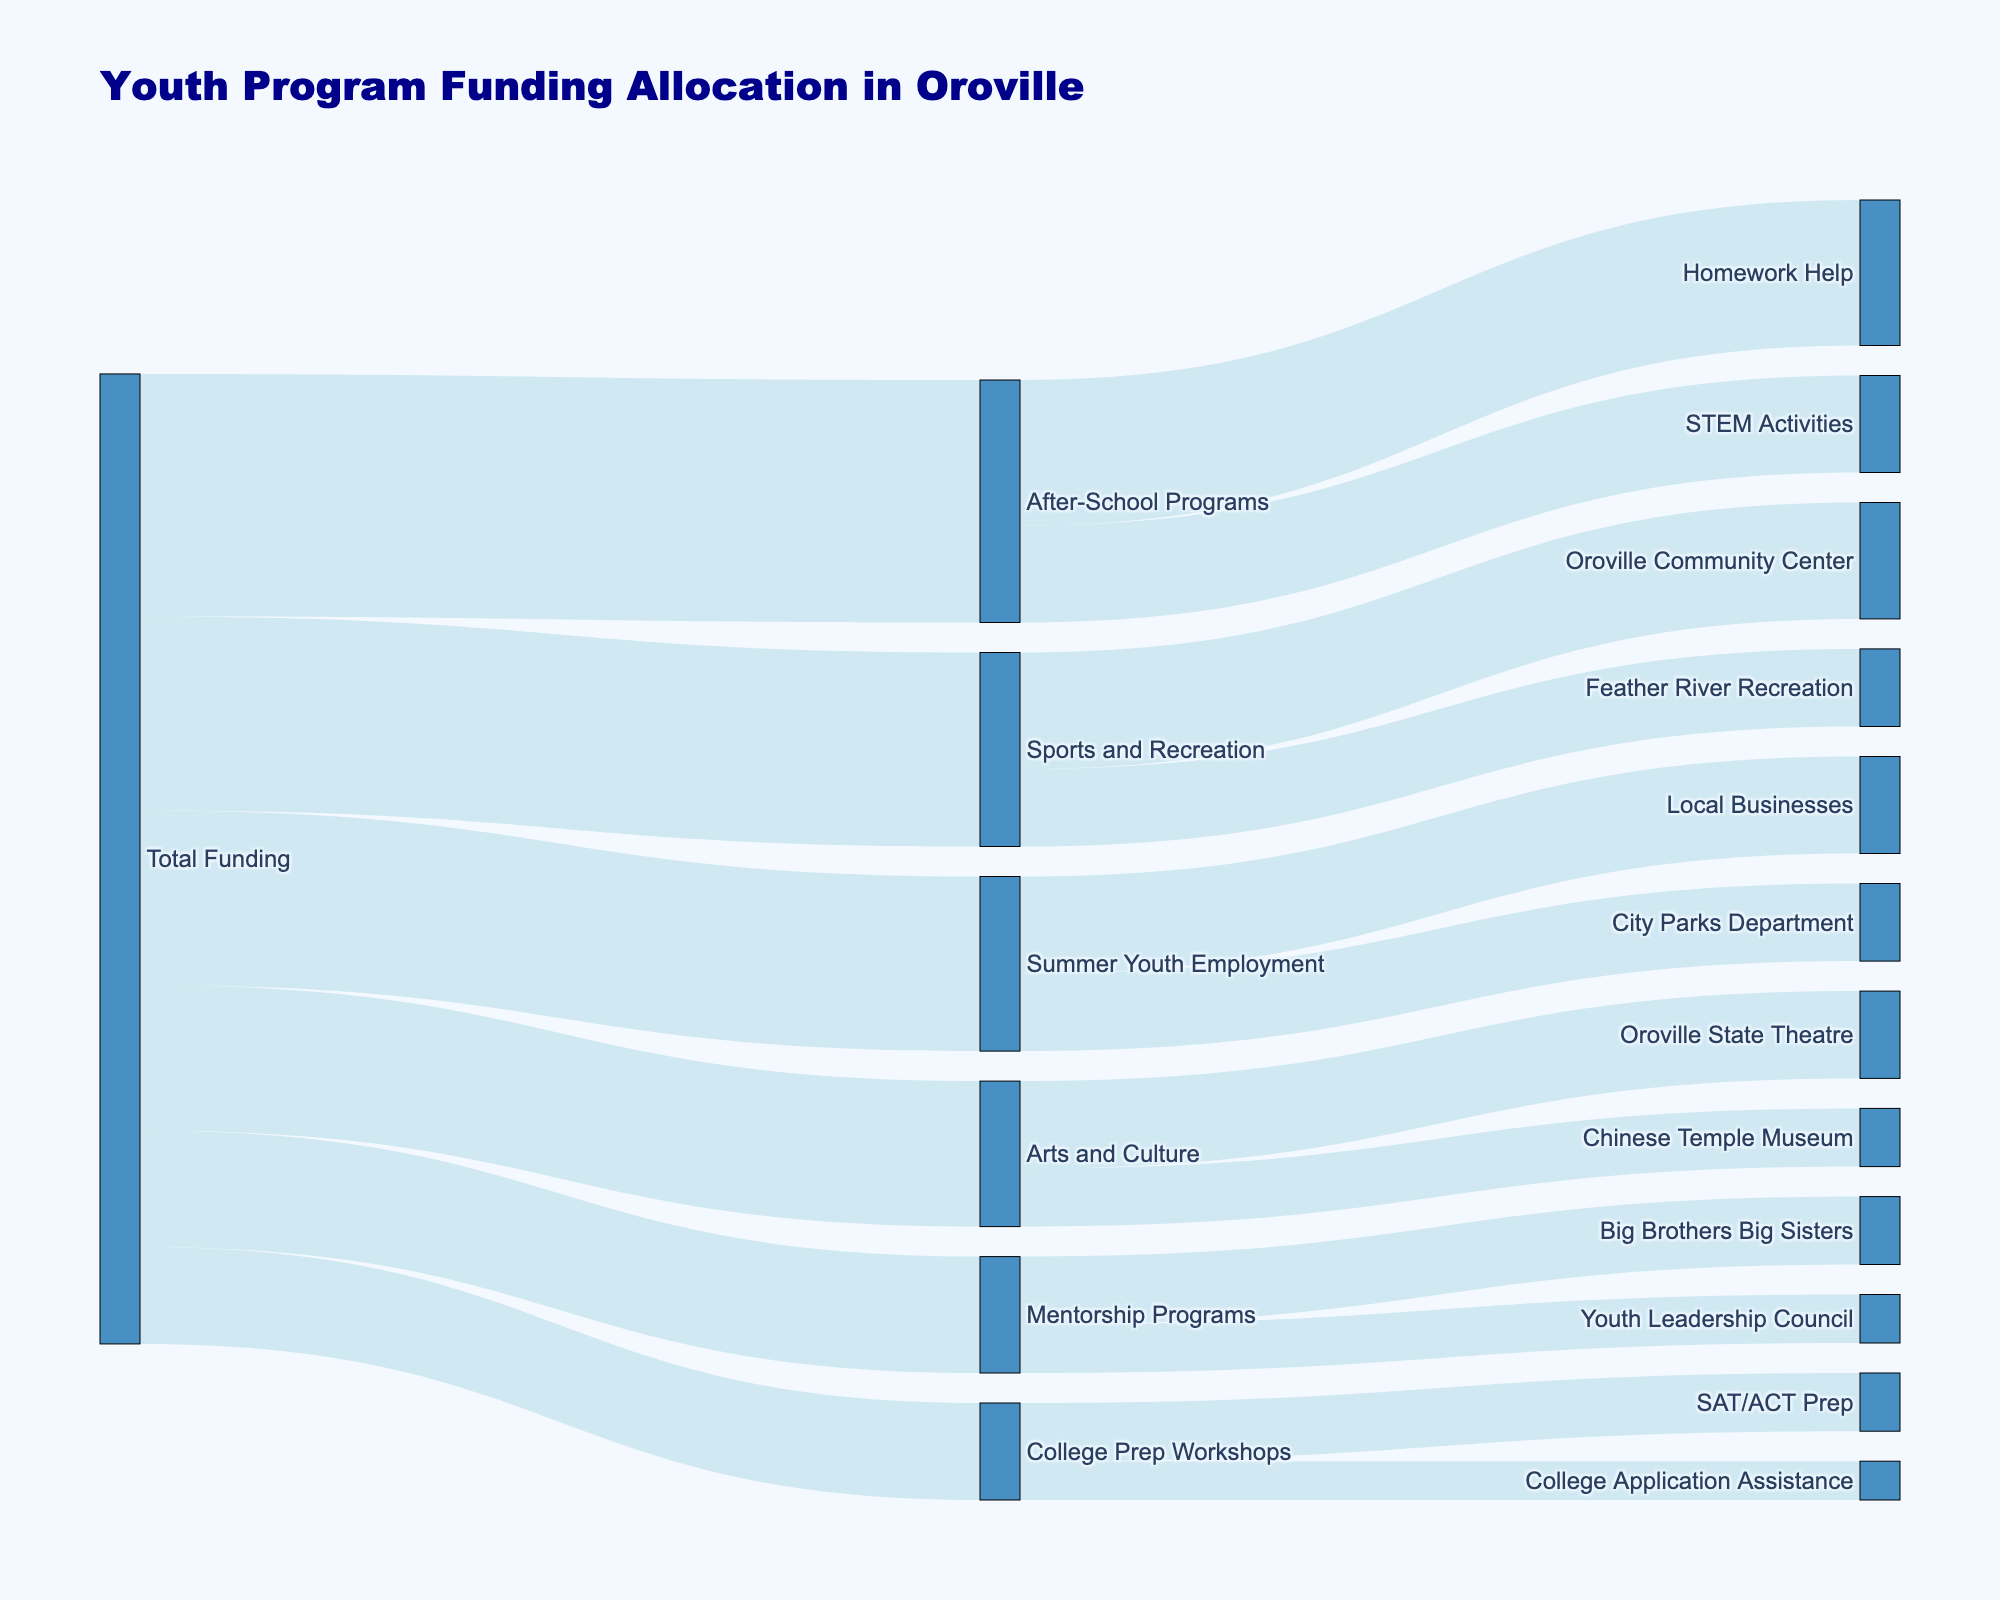Which initiative received the highest amount of total funding? By looking at the initial nodes branching out from "Total Funding," After-School Programs appears to have received the highest funding amount of $250,000.
Answer: After-School Programs How much funding was allocated to Mentorship Programs? By examining the flow coming from "Total Funding" to "Mentorship Programs," it shows an allocation of $120,000.
Answer: $120,000 What is the combined funding allocated to Homework Help and STEM Activities? Homework Help received $150,000 and STEM Activities received $100,000. Adding these together gives $150,000 + $100,000 = $250,000.
Answer: $250,000 Which specific program within Sports and Recreation received more funding? Between the Oroville Community Center and Feather River Recreation, the Oroville Community Center received $120,000 while Feather River Recreation received $80,000. Thus, the Oroville Community Center received more funding.
Answer: Oroville Community Center What is the total funding dedicated to Summer Youth Employment? By tracing the flows connected to Summer Youth Employment, City Parks Department received $80,000 and Local Businesses received $100,000. Summing these gives $80,000 + $100,000 = $180,000.
Answer: $180,000 How does the funding for College Prep Workshops compare to Arts and Culture programs? College Prep Workshops received $100,000 in total (SAT/ACT Prep: $60,000, College Application Assistance: $40,000), whereas Arts and Culture programs received $150,000 in total (Oroville State Theatre: $90,000, Chinese Temple Museum: $60,000). Arts and Culture received more funding than College Prep Workshops.
Answer: Arts and Culture received more funding What portion of the funding for After-School Programs went to STEM Activities? Out of the $250,000 allocated to After-School Programs, STEM Activities received $100,000. The portion is calculated as $100,000 / $250,000 = 0.4 or 40%.
Answer: 40% Is the funding for Local Businesses within the Summer Youth Employment program greater than the funding for Chinese Temple Museum within Arts and Culture? Local Businesses received $100,000 while the Chinese Temple Museum received $60,000. Thus, the funding for Local Businesses is greater.
Answer: Yes What is the total amount of funding originating from Total Funding? Summing up the total funding to all the initiatives: $250,000 (After-School Programs) + $180,000 (Summer Youth Employment) + $120,000 (Mentorship Programs) + $200,000 (Sports and Recreation) + $150,000 (Arts and Culture) + $100,000 (College Prep Workshops) = $1,000,000.
Answer: $1,000,000 Which specific area under Mentorship Programs received less funding? Big Brothers Big Sisters received $70,000 while Youth Leadership Council received $50,000. Therefore, Youth Leadership Council received less funding.
Answer: Youth Leadership Council 